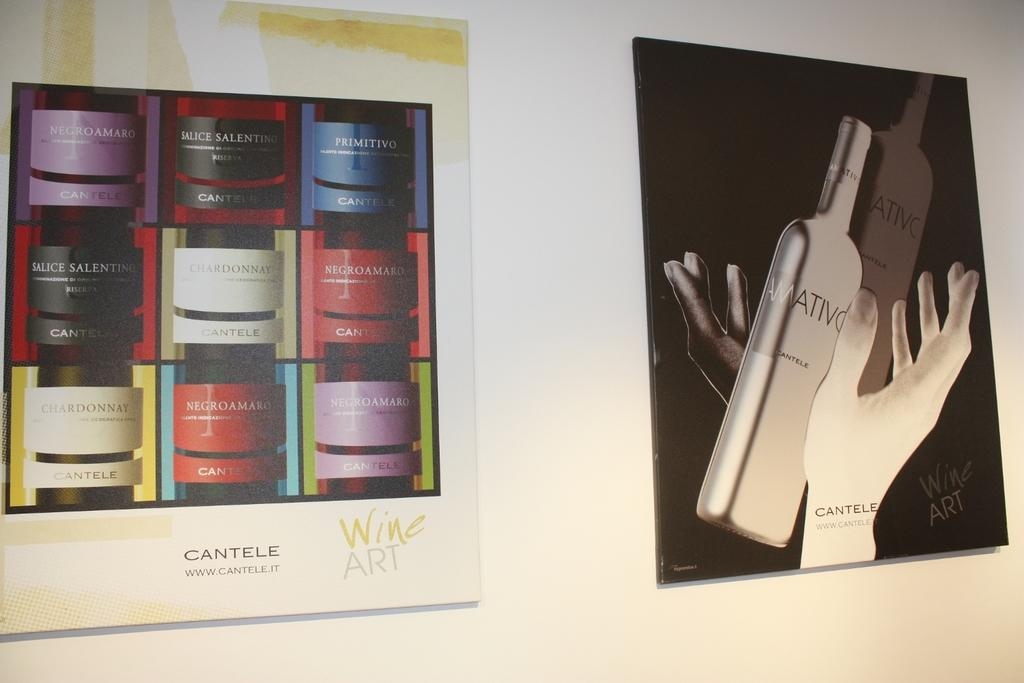What is present on the wall in the image? There are photo frames on the wall in the image. Can you describe the location of one of the photo frames? One of the photo frames is on the right side. What is depicted in the photo frame on the right side? The photo frame on the right side contains a picture of bottles and the hands of a person. What time does the clock in the photo frame on the right side show? There is no clock present in the photo frame on the right side; it contains a picture of bottles and the hands of a person. 